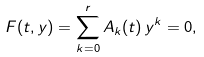<formula> <loc_0><loc_0><loc_500><loc_500>F ( t , y ) = \sum _ { k = 0 } ^ { r } A _ { k } ( t ) \, y ^ { k } = 0 ,</formula> 